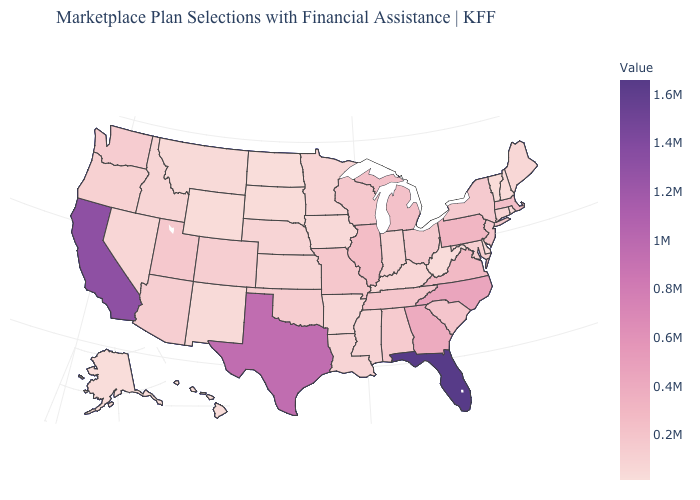Among the states that border Montana , which have the lowest value?
Be succinct. North Dakota. Which states have the lowest value in the Northeast?
Short answer required. Vermont. Does Michigan have the highest value in the MidWest?
Give a very brief answer. No. Does Utah have the lowest value in the USA?
Keep it brief. No. 